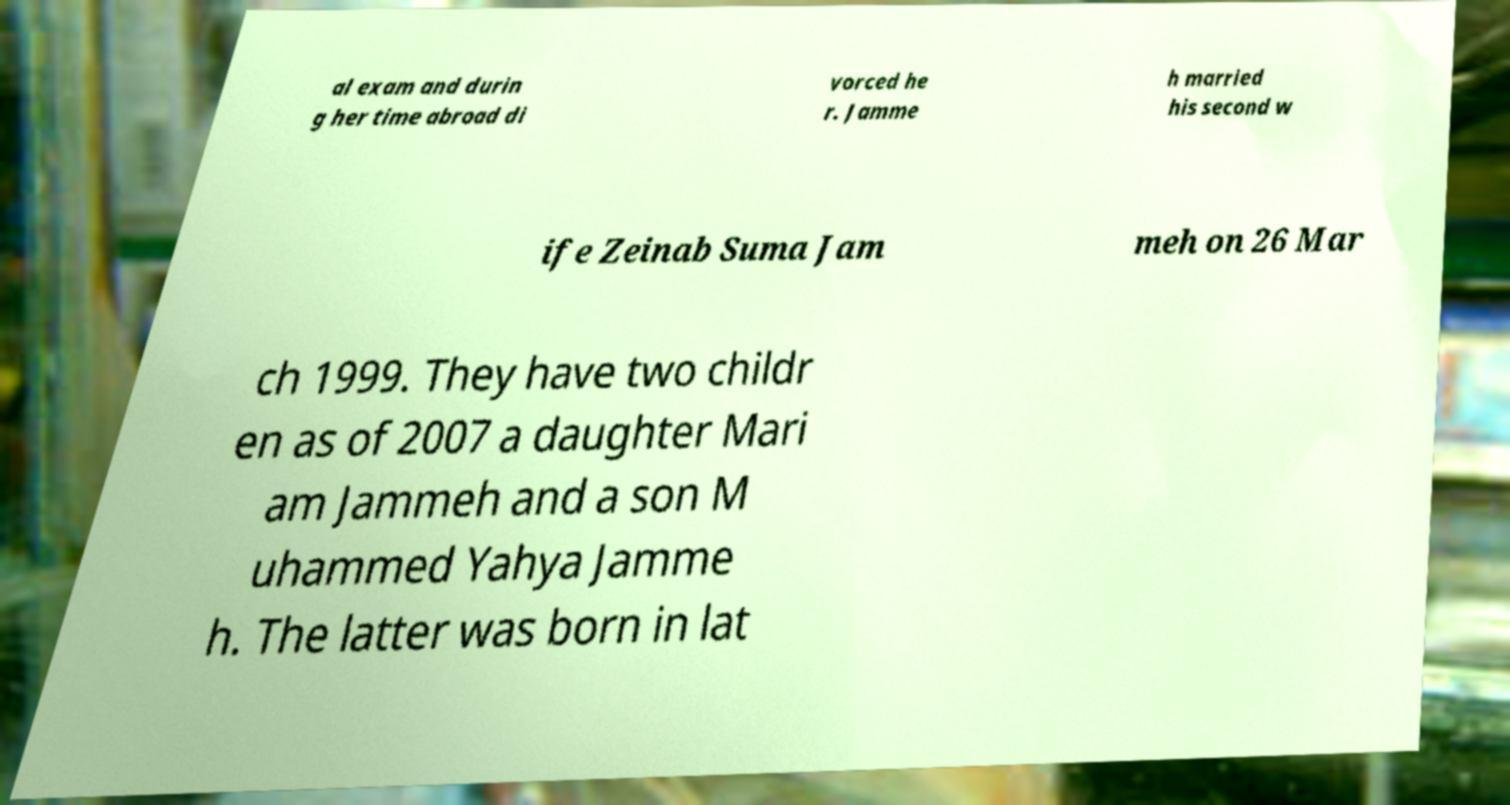Could you extract and type out the text from this image? al exam and durin g her time abroad di vorced he r. Jamme h married his second w ife Zeinab Suma Jam meh on 26 Mar ch 1999. They have two childr en as of 2007 a daughter Mari am Jammeh and a son M uhammed Yahya Jamme h. The latter was born in lat 